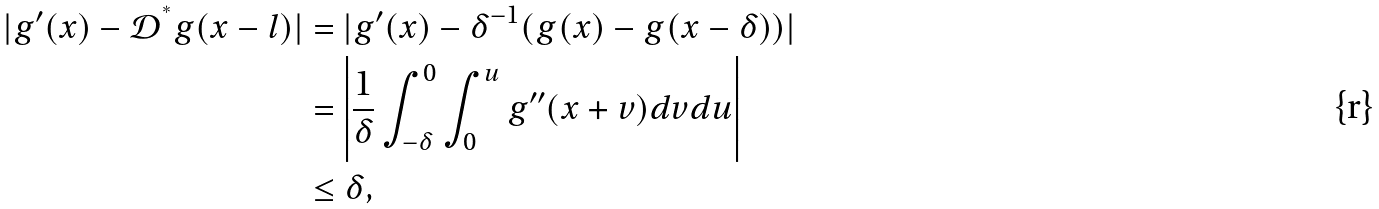<formula> <loc_0><loc_0><loc_500><loc_500>| g ^ { \prime } ( x ) - \mathcal { D } ^ { ^ { * } } g ( x - l ) | & = | g ^ { \prime } ( x ) - \delta ^ { - 1 } ( g ( x ) - g ( x - \delta ) ) | \\ & = \left | \frac { 1 } { \delta } \int _ { - \delta } ^ { 0 } \int _ { 0 } ^ { u } g ^ { \prime \prime } ( x + v ) d v d u \right | \\ & \leq \delta ,</formula> 